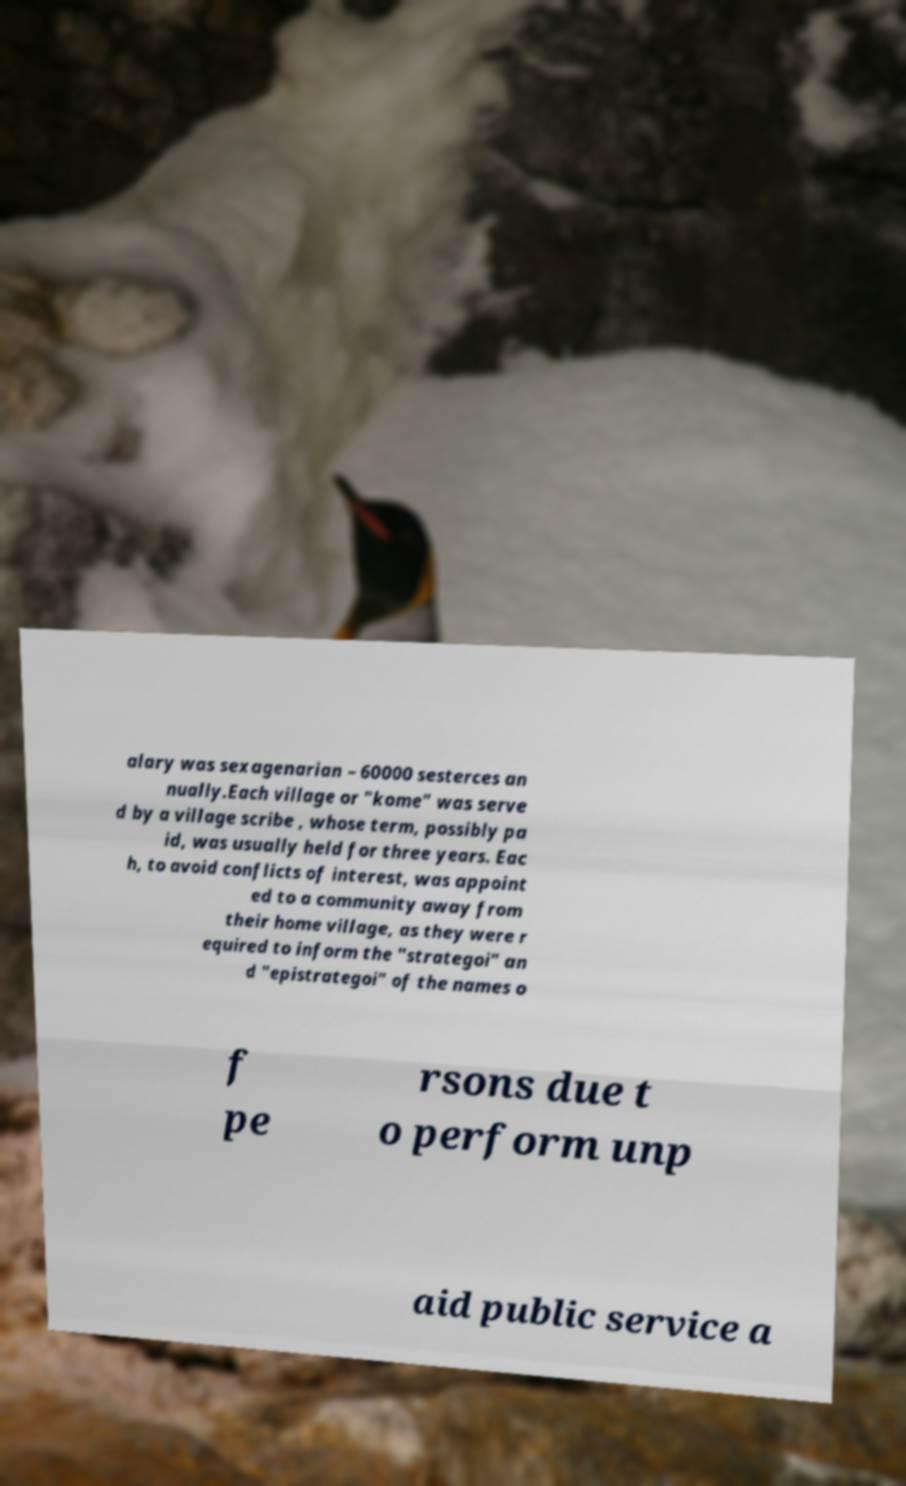Please read and relay the text visible in this image. What does it say? alary was sexagenarian – 60000 sesterces an nually.Each village or "kome" was serve d by a village scribe , whose term, possibly pa id, was usually held for three years. Eac h, to avoid conflicts of interest, was appoint ed to a community away from their home village, as they were r equired to inform the "strategoi" an d "epistrategoi" of the names o f pe rsons due t o perform unp aid public service a 